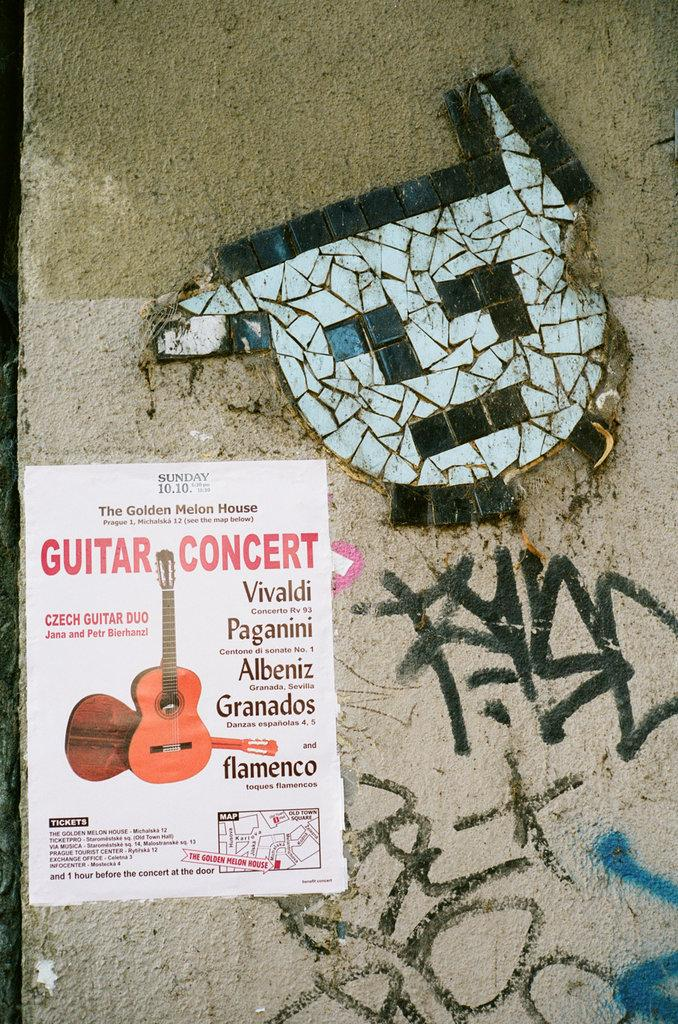<image>
Relay a brief, clear account of the picture shown. A poster on a wall promoting a guitar concert. 